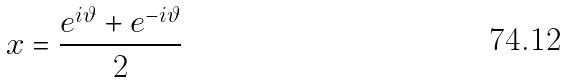Convert formula to latex. <formula><loc_0><loc_0><loc_500><loc_500>x = \frac { e ^ { i \vartheta } + e ^ { - i \vartheta } } { 2 }</formula> 